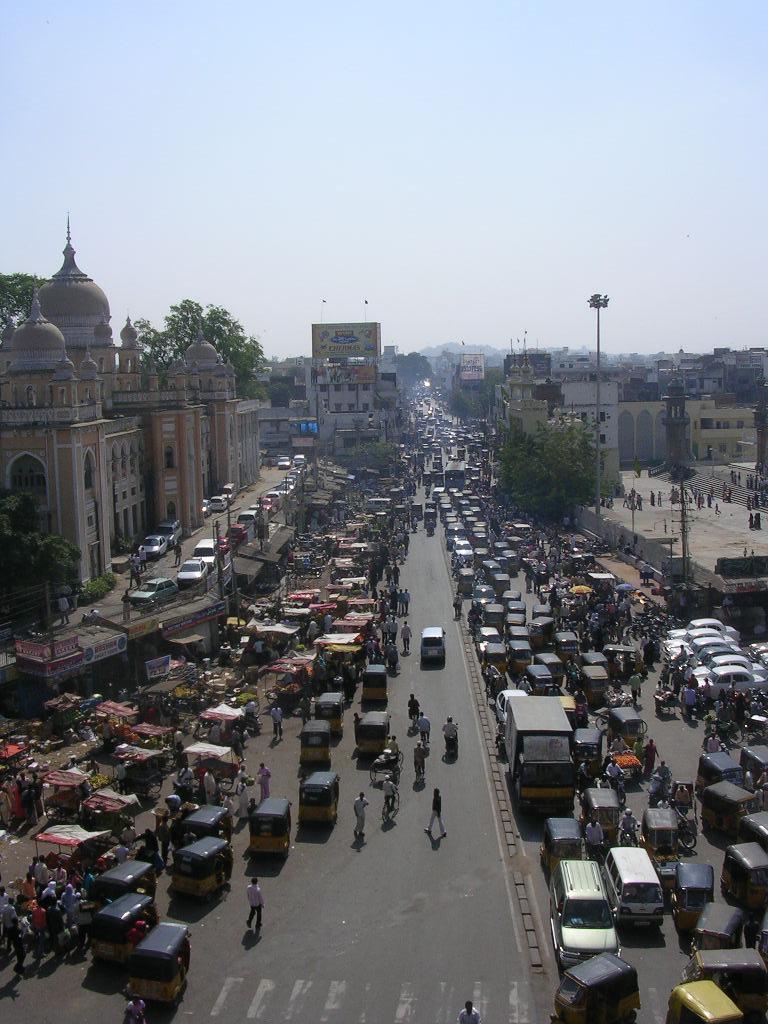In one or two sentences, can you explain what this image depicts? In this picture we can observe a road on which there are some vehicles moving. We can observe buildings and trees. In the background there is a sky. 